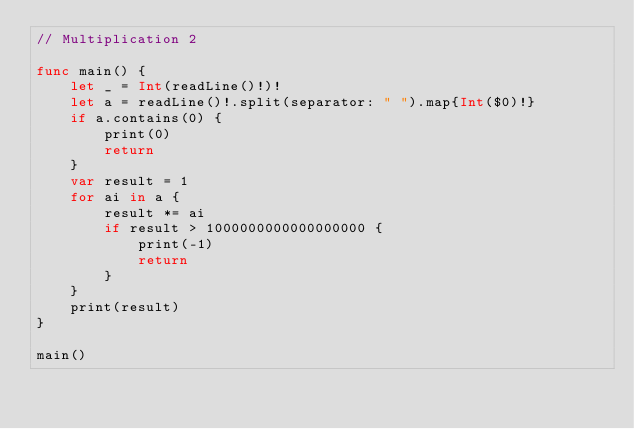<code> <loc_0><loc_0><loc_500><loc_500><_Swift_>// Multiplication 2

func main() {
    let _ = Int(readLine()!)!
    let a = readLine()!.split(separator: " ").map{Int($0)!}
    if a.contains(0) {
        print(0)
        return
    }
    var result = 1
    for ai in a {
        result *= ai
        if result > 1000000000000000000 {
            print(-1)
            return
        }
    }
    print(result)
}

main()</code> 